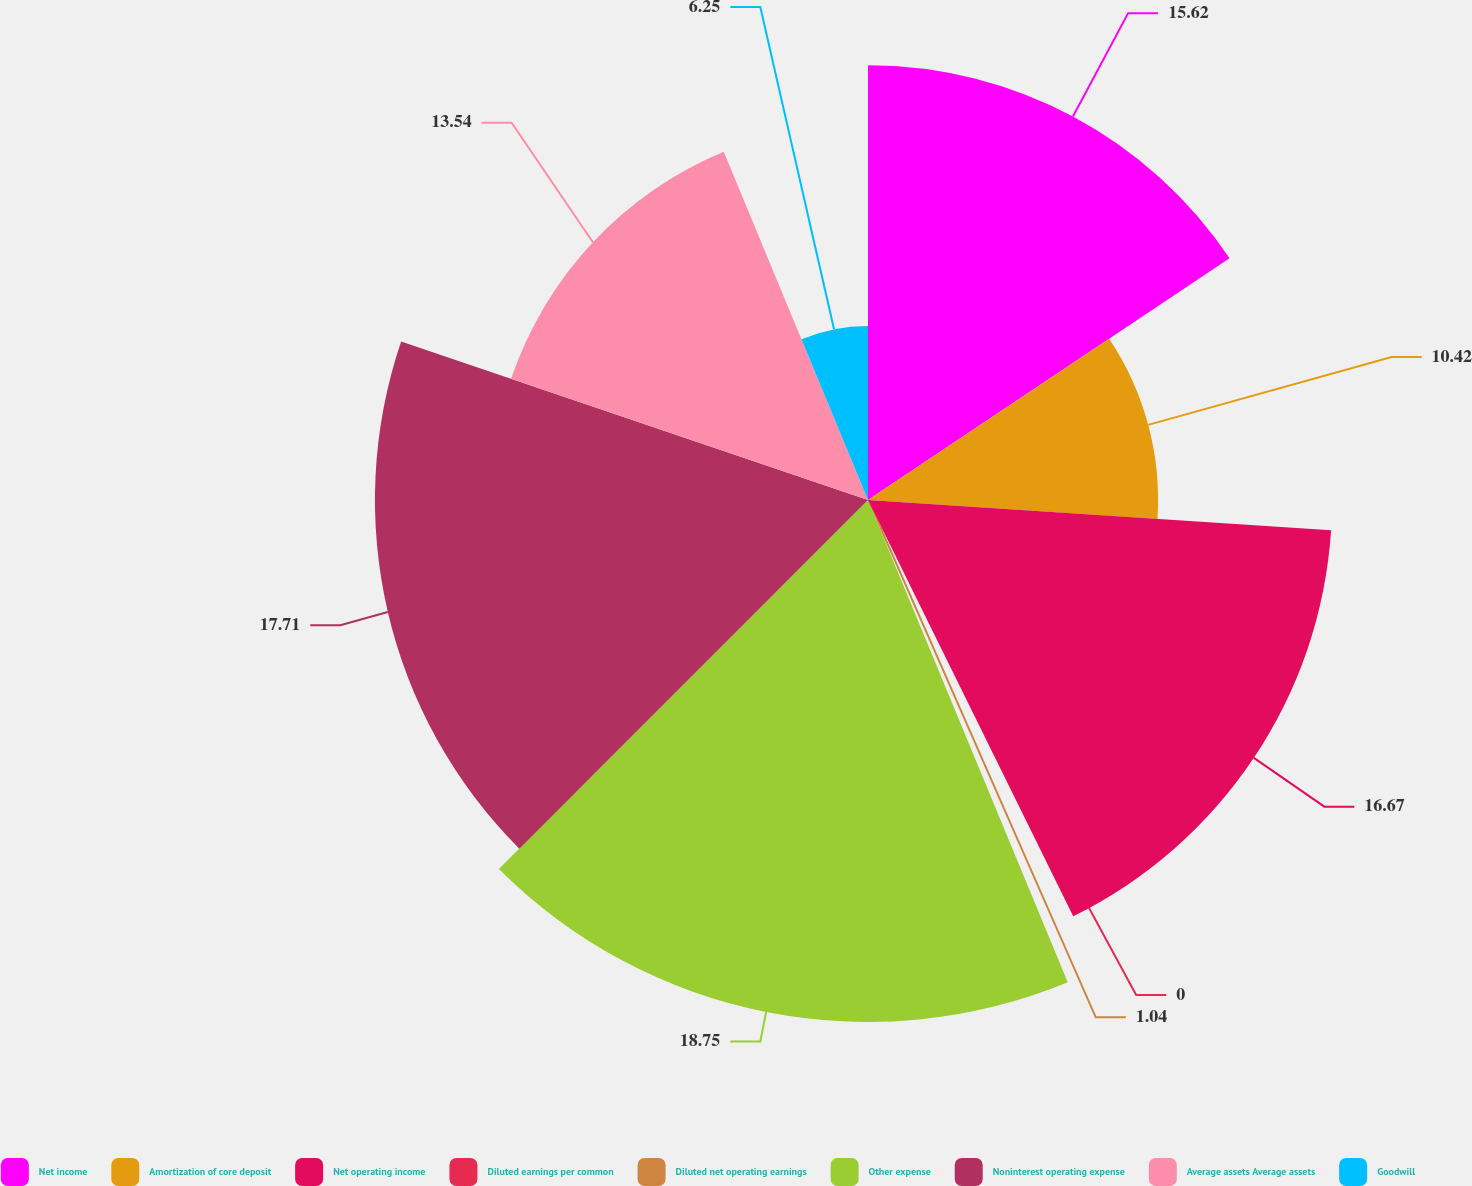Convert chart. <chart><loc_0><loc_0><loc_500><loc_500><pie_chart><fcel>Net income<fcel>Amortization of core deposit<fcel>Net operating income<fcel>Diluted earnings per common<fcel>Diluted net operating earnings<fcel>Other expense<fcel>Noninterest operating expense<fcel>Average assets Average assets<fcel>Goodwill<nl><fcel>15.62%<fcel>10.42%<fcel>16.67%<fcel>0.0%<fcel>1.04%<fcel>18.75%<fcel>17.71%<fcel>13.54%<fcel>6.25%<nl></chart> 